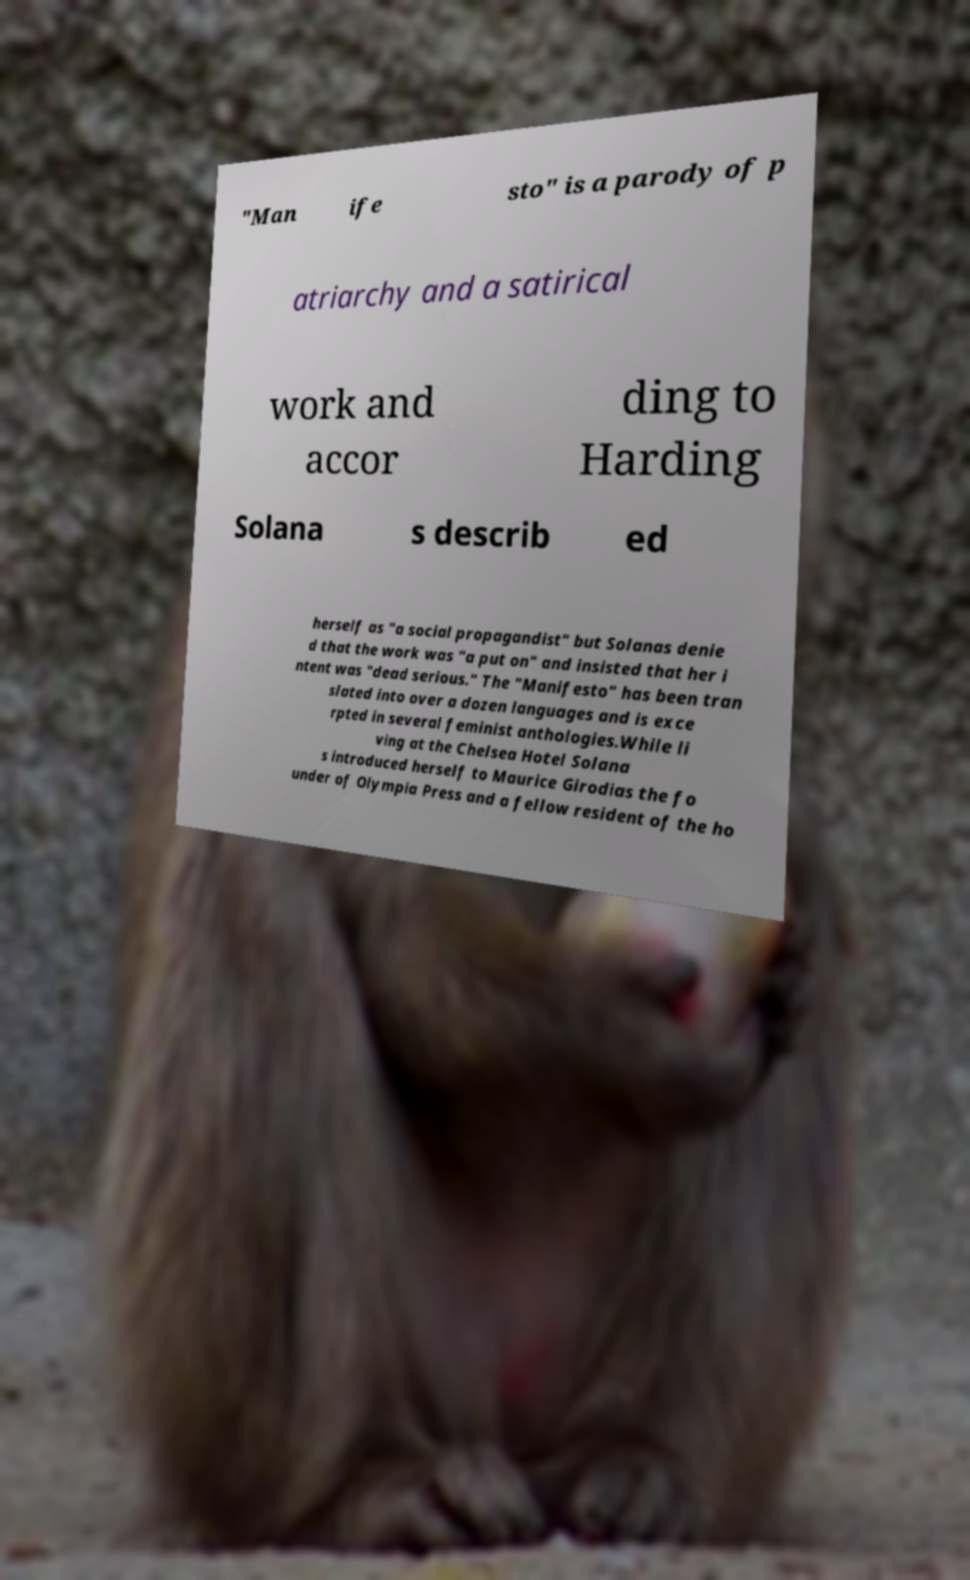There's text embedded in this image that I need extracted. Can you transcribe it verbatim? "Man ife sto" is a parody of p atriarchy and a satirical work and accor ding to Harding Solana s describ ed herself as "a social propagandist" but Solanas denie d that the work was "a put on" and insisted that her i ntent was "dead serious." The "Manifesto" has been tran slated into over a dozen languages and is exce rpted in several feminist anthologies.While li ving at the Chelsea Hotel Solana s introduced herself to Maurice Girodias the fo under of Olympia Press and a fellow resident of the ho 